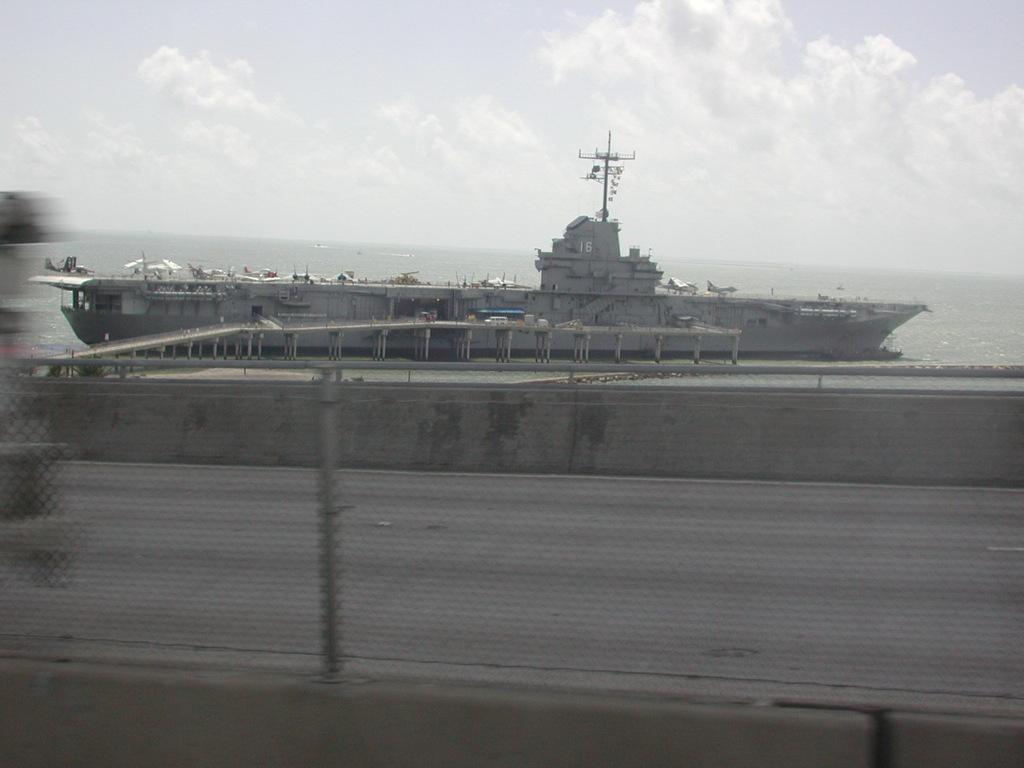Please provide a concise description of this image. In the picture we can see a ship is floating on the water. Here we can see the wall and in the background, we can see the cloudy sky. The left side of the image is slightly blurred. 